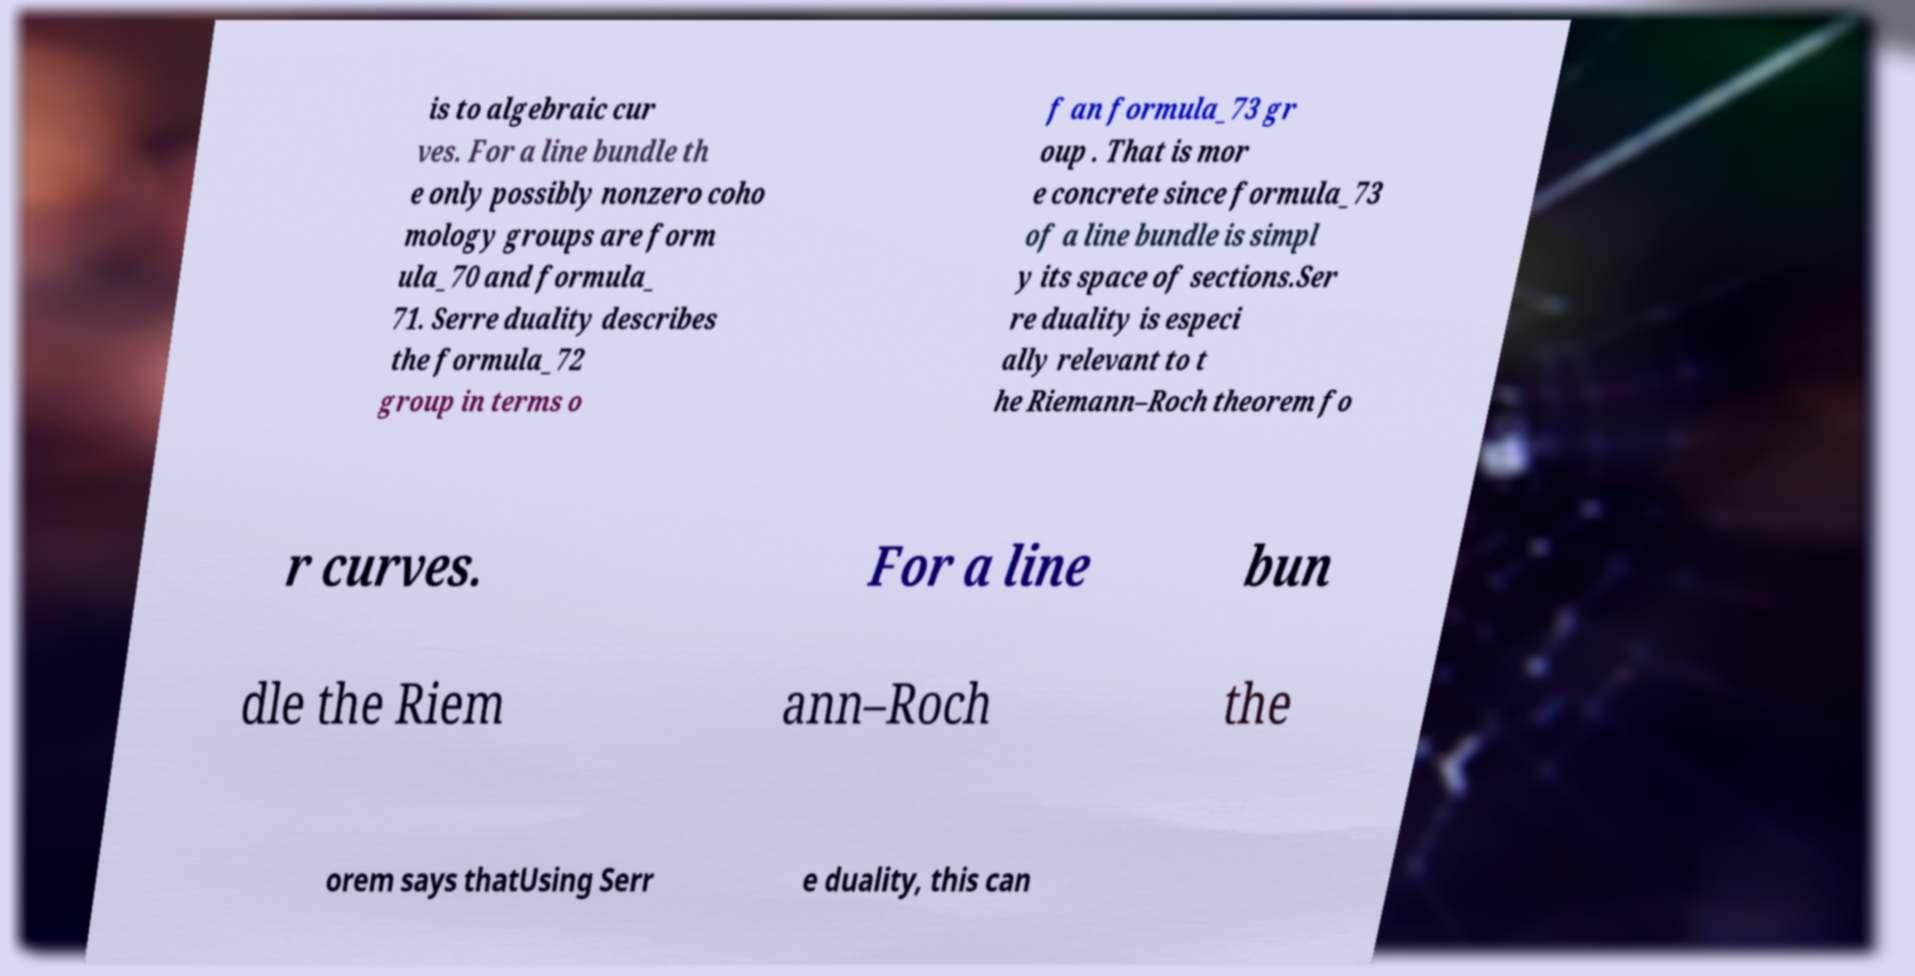I need the written content from this picture converted into text. Can you do that? is to algebraic cur ves. For a line bundle th e only possibly nonzero coho mology groups are form ula_70 and formula_ 71. Serre duality describes the formula_72 group in terms o f an formula_73 gr oup . That is mor e concrete since formula_73 of a line bundle is simpl y its space of sections.Ser re duality is especi ally relevant to t he Riemann–Roch theorem fo r curves. For a line bun dle the Riem ann–Roch the orem says thatUsing Serr e duality, this can 